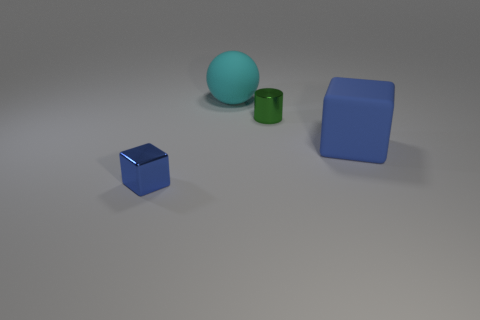Add 3 big spheres. How many objects exist? 7 Subtract all cylinders. How many objects are left? 3 Subtract 0 purple balls. How many objects are left? 4 Subtract all metal cubes. Subtract all metallic cylinders. How many objects are left? 2 Add 4 blue metallic blocks. How many blue metallic blocks are left? 5 Add 1 shiny objects. How many shiny objects exist? 3 